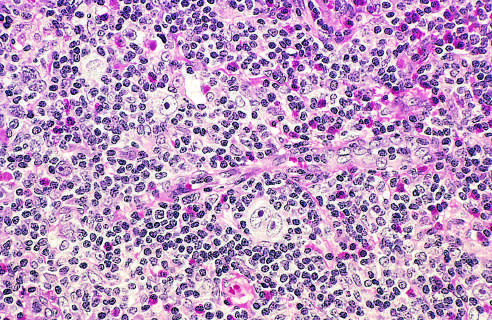s the arteriolar wall surrounded by eosinophils, lymphocytes, and histiocytes?
Answer the question using a single word or phrase. No 